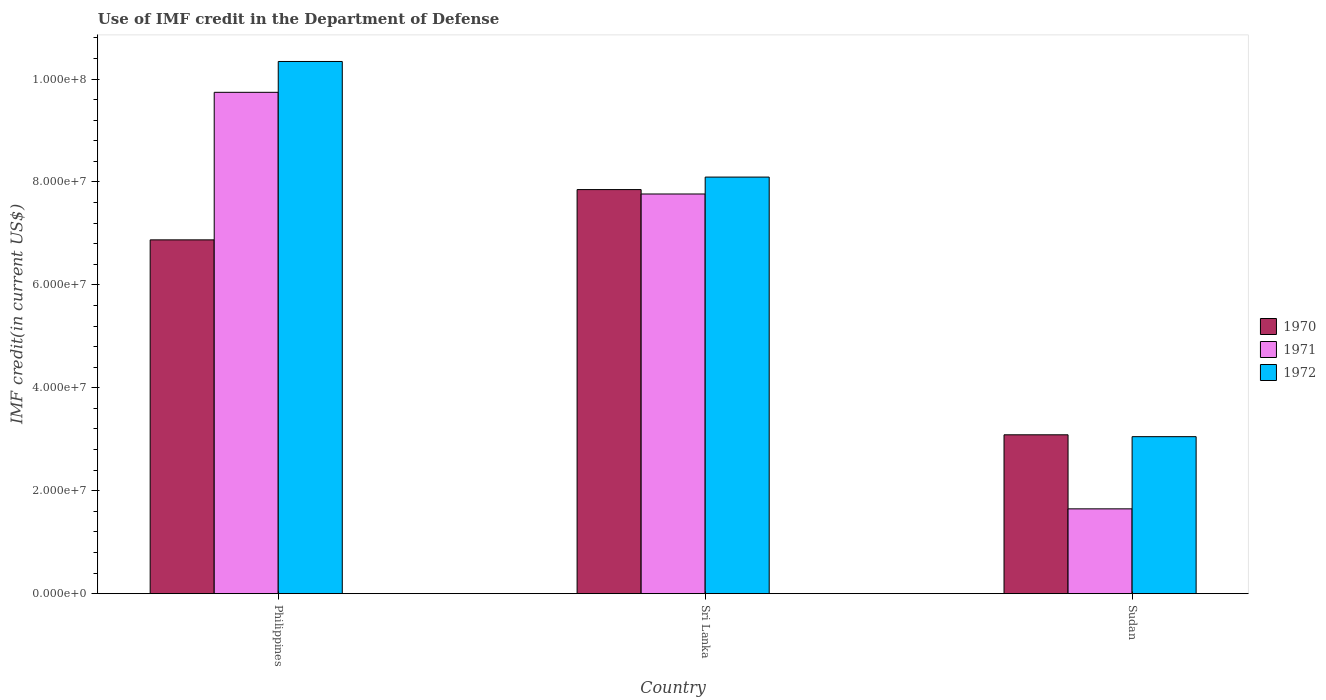How many different coloured bars are there?
Give a very brief answer. 3. How many bars are there on the 3rd tick from the right?
Give a very brief answer. 3. What is the label of the 2nd group of bars from the left?
Your answer should be compact. Sri Lanka. What is the IMF credit in the Department of Defense in 1972 in Philippines?
Make the answer very short. 1.03e+08. Across all countries, what is the maximum IMF credit in the Department of Defense in 1972?
Your answer should be compact. 1.03e+08. Across all countries, what is the minimum IMF credit in the Department of Defense in 1972?
Your answer should be very brief. 3.05e+07. In which country was the IMF credit in the Department of Defense in 1970 minimum?
Provide a succinct answer. Sudan. What is the total IMF credit in the Department of Defense in 1972 in the graph?
Offer a terse response. 2.15e+08. What is the difference between the IMF credit in the Department of Defense in 1970 in Philippines and that in Sri Lanka?
Offer a very short reply. -9.77e+06. What is the difference between the IMF credit in the Department of Defense in 1972 in Sri Lanka and the IMF credit in the Department of Defense in 1971 in Philippines?
Ensure brevity in your answer.  -1.65e+07. What is the average IMF credit in the Department of Defense in 1970 per country?
Your response must be concise. 5.94e+07. What is the difference between the IMF credit in the Department of Defense of/in 1972 and IMF credit in the Department of Defense of/in 1971 in Philippines?
Your response must be concise. 5.99e+06. What is the ratio of the IMF credit in the Department of Defense in 1972 in Sri Lanka to that in Sudan?
Your answer should be compact. 2.65. Is the IMF credit in the Department of Defense in 1972 in Philippines less than that in Sudan?
Your answer should be compact. No. Is the difference between the IMF credit in the Department of Defense in 1972 in Philippines and Sri Lanka greater than the difference between the IMF credit in the Department of Defense in 1971 in Philippines and Sri Lanka?
Provide a succinct answer. Yes. What is the difference between the highest and the second highest IMF credit in the Department of Defense in 1970?
Ensure brevity in your answer.  4.76e+07. What is the difference between the highest and the lowest IMF credit in the Department of Defense in 1970?
Your answer should be compact. 4.76e+07. In how many countries, is the IMF credit in the Department of Defense in 1972 greater than the average IMF credit in the Department of Defense in 1972 taken over all countries?
Make the answer very short. 2. What does the 3rd bar from the left in Sudan represents?
Offer a very short reply. 1972. What does the 1st bar from the right in Sudan represents?
Your response must be concise. 1972. Is it the case that in every country, the sum of the IMF credit in the Department of Defense in 1971 and IMF credit in the Department of Defense in 1972 is greater than the IMF credit in the Department of Defense in 1970?
Your response must be concise. Yes. Are all the bars in the graph horizontal?
Your response must be concise. No. What is the difference between two consecutive major ticks on the Y-axis?
Keep it short and to the point. 2.00e+07. Are the values on the major ticks of Y-axis written in scientific E-notation?
Your answer should be compact. Yes. Does the graph contain any zero values?
Offer a terse response. No. Does the graph contain grids?
Your answer should be compact. No. Where does the legend appear in the graph?
Ensure brevity in your answer.  Center right. How many legend labels are there?
Your answer should be compact. 3. How are the legend labels stacked?
Keep it short and to the point. Vertical. What is the title of the graph?
Offer a terse response. Use of IMF credit in the Department of Defense. What is the label or title of the Y-axis?
Ensure brevity in your answer.  IMF credit(in current US$). What is the IMF credit(in current US$) in 1970 in Philippines?
Ensure brevity in your answer.  6.88e+07. What is the IMF credit(in current US$) of 1971 in Philippines?
Keep it short and to the point. 9.74e+07. What is the IMF credit(in current US$) in 1972 in Philippines?
Ensure brevity in your answer.  1.03e+08. What is the IMF credit(in current US$) of 1970 in Sri Lanka?
Provide a short and direct response. 7.85e+07. What is the IMF credit(in current US$) in 1971 in Sri Lanka?
Keep it short and to the point. 7.77e+07. What is the IMF credit(in current US$) of 1972 in Sri Lanka?
Provide a short and direct response. 8.10e+07. What is the IMF credit(in current US$) in 1970 in Sudan?
Keep it short and to the point. 3.09e+07. What is the IMF credit(in current US$) of 1971 in Sudan?
Keep it short and to the point. 1.65e+07. What is the IMF credit(in current US$) of 1972 in Sudan?
Your response must be concise. 3.05e+07. Across all countries, what is the maximum IMF credit(in current US$) of 1970?
Give a very brief answer. 7.85e+07. Across all countries, what is the maximum IMF credit(in current US$) of 1971?
Provide a short and direct response. 9.74e+07. Across all countries, what is the maximum IMF credit(in current US$) of 1972?
Provide a succinct answer. 1.03e+08. Across all countries, what is the minimum IMF credit(in current US$) of 1970?
Your answer should be very brief. 3.09e+07. Across all countries, what is the minimum IMF credit(in current US$) of 1971?
Give a very brief answer. 1.65e+07. Across all countries, what is the minimum IMF credit(in current US$) of 1972?
Your answer should be compact. 3.05e+07. What is the total IMF credit(in current US$) of 1970 in the graph?
Your answer should be very brief. 1.78e+08. What is the total IMF credit(in current US$) of 1971 in the graph?
Make the answer very short. 1.92e+08. What is the total IMF credit(in current US$) of 1972 in the graph?
Provide a short and direct response. 2.15e+08. What is the difference between the IMF credit(in current US$) of 1970 in Philippines and that in Sri Lanka?
Ensure brevity in your answer.  -9.77e+06. What is the difference between the IMF credit(in current US$) of 1971 in Philippines and that in Sri Lanka?
Give a very brief answer. 1.98e+07. What is the difference between the IMF credit(in current US$) in 1972 in Philippines and that in Sri Lanka?
Make the answer very short. 2.25e+07. What is the difference between the IMF credit(in current US$) of 1970 in Philippines and that in Sudan?
Provide a succinct answer. 3.79e+07. What is the difference between the IMF credit(in current US$) in 1971 in Philippines and that in Sudan?
Ensure brevity in your answer.  8.09e+07. What is the difference between the IMF credit(in current US$) in 1972 in Philippines and that in Sudan?
Provide a short and direct response. 7.29e+07. What is the difference between the IMF credit(in current US$) of 1970 in Sri Lanka and that in Sudan?
Provide a short and direct response. 4.76e+07. What is the difference between the IMF credit(in current US$) of 1971 in Sri Lanka and that in Sudan?
Make the answer very short. 6.12e+07. What is the difference between the IMF credit(in current US$) of 1972 in Sri Lanka and that in Sudan?
Offer a terse response. 5.04e+07. What is the difference between the IMF credit(in current US$) of 1970 in Philippines and the IMF credit(in current US$) of 1971 in Sri Lanka?
Make the answer very short. -8.91e+06. What is the difference between the IMF credit(in current US$) in 1970 in Philippines and the IMF credit(in current US$) in 1972 in Sri Lanka?
Give a very brief answer. -1.22e+07. What is the difference between the IMF credit(in current US$) of 1971 in Philippines and the IMF credit(in current US$) of 1972 in Sri Lanka?
Give a very brief answer. 1.65e+07. What is the difference between the IMF credit(in current US$) in 1970 in Philippines and the IMF credit(in current US$) in 1971 in Sudan?
Ensure brevity in your answer.  5.23e+07. What is the difference between the IMF credit(in current US$) of 1970 in Philippines and the IMF credit(in current US$) of 1972 in Sudan?
Provide a short and direct response. 3.82e+07. What is the difference between the IMF credit(in current US$) in 1971 in Philippines and the IMF credit(in current US$) in 1972 in Sudan?
Your response must be concise. 6.69e+07. What is the difference between the IMF credit(in current US$) of 1970 in Sri Lanka and the IMF credit(in current US$) of 1971 in Sudan?
Your answer should be very brief. 6.20e+07. What is the difference between the IMF credit(in current US$) in 1970 in Sri Lanka and the IMF credit(in current US$) in 1972 in Sudan?
Provide a short and direct response. 4.80e+07. What is the difference between the IMF credit(in current US$) in 1971 in Sri Lanka and the IMF credit(in current US$) in 1972 in Sudan?
Keep it short and to the point. 4.72e+07. What is the average IMF credit(in current US$) in 1970 per country?
Offer a terse response. 5.94e+07. What is the average IMF credit(in current US$) of 1971 per country?
Provide a short and direct response. 6.39e+07. What is the average IMF credit(in current US$) in 1972 per country?
Your response must be concise. 7.16e+07. What is the difference between the IMF credit(in current US$) of 1970 and IMF credit(in current US$) of 1971 in Philippines?
Offer a terse response. -2.87e+07. What is the difference between the IMF credit(in current US$) of 1970 and IMF credit(in current US$) of 1972 in Philippines?
Keep it short and to the point. -3.47e+07. What is the difference between the IMF credit(in current US$) of 1971 and IMF credit(in current US$) of 1972 in Philippines?
Offer a very short reply. -5.99e+06. What is the difference between the IMF credit(in current US$) of 1970 and IMF credit(in current US$) of 1971 in Sri Lanka?
Give a very brief answer. 8.56e+05. What is the difference between the IMF credit(in current US$) in 1970 and IMF credit(in current US$) in 1972 in Sri Lanka?
Provide a short and direct response. -2.43e+06. What is the difference between the IMF credit(in current US$) of 1971 and IMF credit(in current US$) of 1972 in Sri Lanka?
Your answer should be compact. -3.29e+06. What is the difference between the IMF credit(in current US$) in 1970 and IMF credit(in current US$) in 1971 in Sudan?
Offer a terse response. 1.44e+07. What is the difference between the IMF credit(in current US$) in 1970 and IMF credit(in current US$) in 1972 in Sudan?
Give a very brief answer. 3.62e+05. What is the difference between the IMF credit(in current US$) in 1971 and IMF credit(in current US$) in 1972 in Sudan?
Your answer should be very brief. -1.40e+07. What is the ratio of the IMF credit(in current US$) in 1970 in Philippines to that in Sri Lanka?
Give a very brief answer. 0.88. What is the ratio of the IMF credit(in current US$) in 1971 in Philippines to that in Sri Lanka?
Your answer should be compact. 1.25. What is the ratio of the IMF credit(in current US$) in 1972 in Philippines to that in Sri Lanka?
Your response must be concise. 1.28. What is the ratio of the IMF credit(in current US$) in 1970 in Philippines to that in Sudan?
Provide a succinct answer. 2.23. What is the ratio of the IMF credit(in current US$) in 1971 in Philippines to that in Sudan?
Provide a short and direct response. 5.91. What is the ratio of the IMF credit(in current US$) of 1972 in Philippines to that in Sudan?
Your answer should be compact. 3.39. What is the ratio of the IMF credit(in current US$) of 1970 in Sri Lanka to that in Sudan?
Provide a succinct answer. 2.54. What is the ratio of the IMF credit(in current US$) in 1971 in Sri Lanka to that in Sudan?
Offer a very short reply. 4.71. What is the ratio of the IMF credit(in current US$) in 1972 in Sri Lanka to that in Sudan?
Keep it short and to the point. 2.65. What is the difference between the highest and the second highest IMF credit(in current US$) of 1970?
Give a very brief answer. 9.77e+06. What is the difference between the highest and the second highest IMF credit(in current US$) in 1971?
Provide a short and direct response. 1.98e+07. What is the difference between the highest and the second highest IMF credit(in current US$) of 1972?
Your answer should be very brief. 2.25e+07. What is the difference between the highest and the lowest IMF credit(in current US$) in 1970?
Make the answer very short. 4.76e+07. What is the difference between the highest and the lowest IMF credit(in current US$) of 1971?
Keep it short and to the point. 8.09e+07. What is the difference between the highest and the lowest IMF credit(in current US$) of 1972?
Your response must be concise. 7.29e+07. 